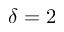Convert formula to latex. <formula><loc_0><loc_0><loc_500><loc_500>\delta = 2</formula> 